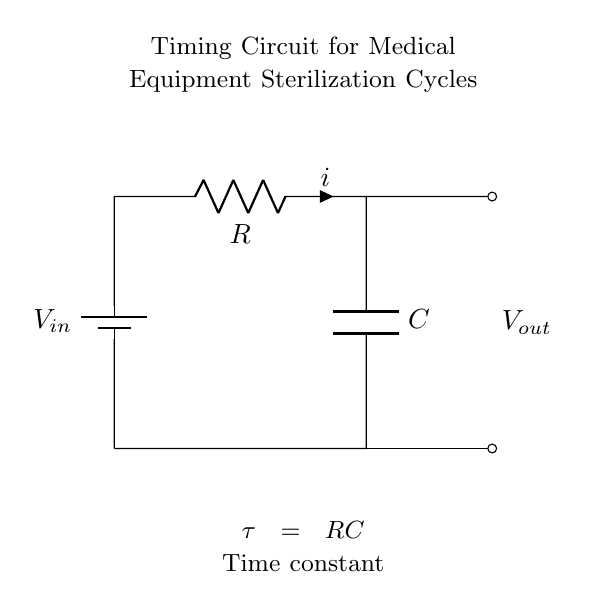What are the components in this circuit? The components in this circuit include a battery, a resistor, and a capacitor. Each component is identified by its symbol on the diagram.
Answer: battery, resistor, capacitor What is the time constant formula for this circuit? The time constant, denoted by tau, is calculated using the formula tau = R * C, where R is the resistance and C is the capacitance. This relationship is indicated in the diagram.
Answer: tau = RC What type of circuit is this? This is a resistor-capacitor timing circuit, commonly used to manage time delays in electronic systems. It combines a resistor and a capacitor in a series arrangement to influence the timing characteristics.
Answer: resistor-capacitor timing circuit What is the output voltage location in the circuit? The output voltage, denoted as Vout, is located at the terminal that connects to the capacitor's discharge path, as shown on the right side of the circuit.
Answer: right side How does the resistor affect the timing cycle of the sterilization process? The resistor controls the rate of charge and discharge of the capacitor, which in turn influences how long the circuit maintains a specific voltage level, thus affecting the timing cycle for the sterilization process.
Answer: it controls the timing cycle What happens when the capacitor reaches full charge? When the capacitor reaches full charge, it will block any further current flow, which stabilizes the voltage across it at the input voltage level. This point is significant for determining the timing duration in the cycle.
Answer: it blocks current flow What does the term 'Vout' refer to in this context? Vout refers to the output voltage that is measured across the capacitor and indicative of the voltage level used in the sterilization cycle timing.
Answer: output voltage 